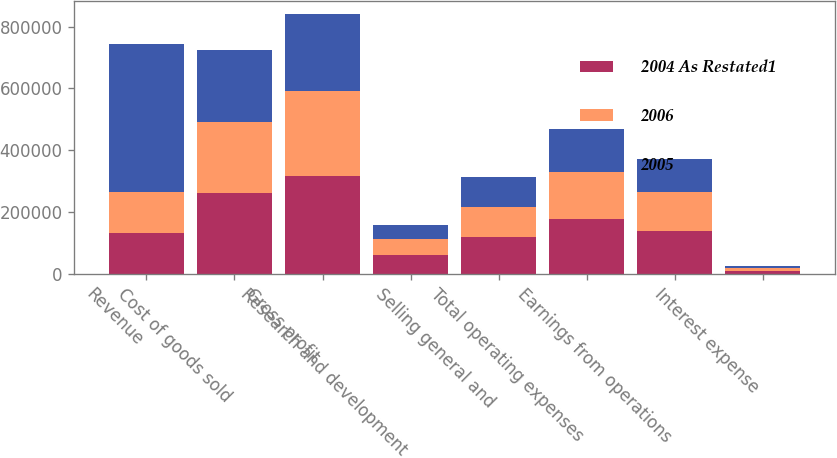Convert chart to OTSL. <chart><loc_0><loc_0><loc_500><loc_500><stacked_bar_chart><ecel><fcel>Revenue<fcel>Cost of goods sold<fcel>Gross profit<fcel>Research and development<fcel>Selling general and<fcel>Total operating expenses<fcel>Earnings from operations<fcel>Interest expense<nl><fcel>2004 As Restated1<fcel>131454<fcel>260087<fcel>314913<fcel>60584<fcel>117374<fcel>177958<fcel>136955<fcel>8956<nl><fcel>2006<fcel>131454<fcel>231867<fcel>276694<fcel>51514<fcel>99227<fcel>150741<fcel>125953<fcel>7922<nl><fcel>2005<fcel>482651<fcel>233492<fcel>249159<fcel>45796<fcel>95605<fcel>141401<fcel>107758<fcel>8092<nl></chart> 